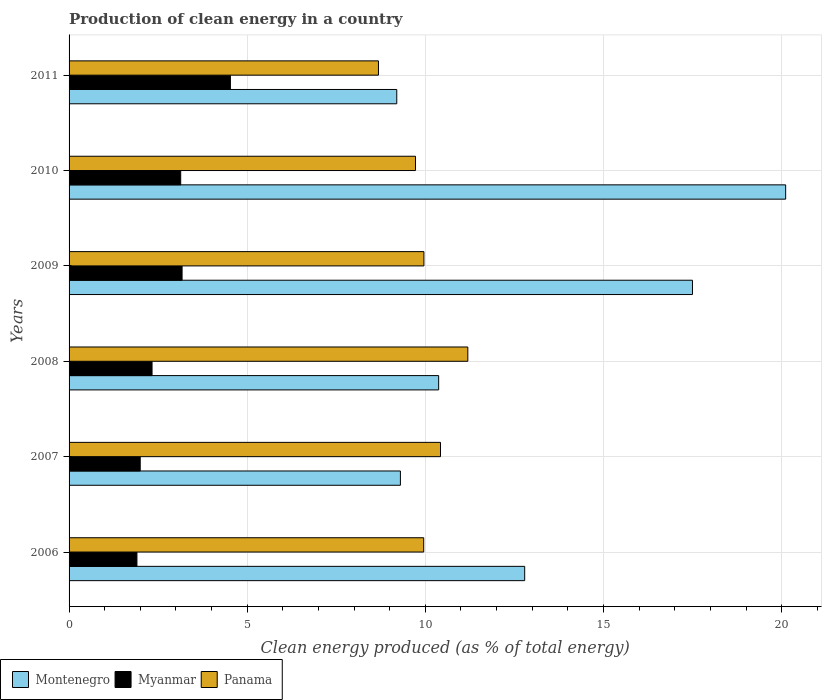How many different coloured bars are there?
Make the answer very short. 3. Are the number of bars per tick equal to the number of legend labels?
Offer a terse response. Yes. How many bars are there on the 2nd tick from the top?
Offer a terse response. 3. What is the label of the 3rd group of bars from the top?
Your answer should be compact. 2009. What is the percentage of clean energy produced in Myanmar in 2011?
Keep it short and to the point. 4.53. Across all years, what is the maximum percentage of clean energy produced in Montenegro?
Give a very brief answer. 20.11. Across all years, what is the minimum percentage of clean energy produced in Myanmar?
Make the answer very short. 1.9. In which year was the percentage of clean energy produced in Myanmar maximum?
Your response must be concise. 2011. What is the total percentage of clean energy produced in Myanmar in the graph?
Ensure brevity in your answer.  17.06. What is the difference between the percentage of clean energy produced in Myanmar in 2007 and that in 2008?
Your answer should be compact. -0.33. What is the difference between the percentage of clean energy produced in Montenegro in 2006 and the percentage of clean energy produced in Myanmar in 2008?
Provide a short and direct response. 10.46. What is the average percentage of clean energy produced in Panama per year?
Your answer should be very brief. 9.99. In the year 2008, what is the difference between the percentage of clean energy produced in Panama and percentage of clean energy produced in Myanmar?
Your response must be concise. 8.86. What is the ratio of the percentage of clean energy produced in Panama in 2006 to that in 2011?
Your response must be concise. 1.15. Is the percentage of clean energy produced in Myanmar in 2006 less than that in 2007?
Keep it short and to the point. Yes. Is the difference between the percentage of clean energy produced in Panama in 2006 and 2011 greater than the difference between the percentage of clean energy produced in Myanmar in 2006 and 2011?
Ensure brevity in your answer.  Yes. What is the difference between the highest and the second highest percentage of clean energy produced in Montenegro?
Give a very brief answer. 2.62. What is the difference between the highest and the lowest percentage of clean energy produced in Panama?
Your answer should be compact. 2.51. Is the sum of the percentage of clean energy produced in Panama in 2006 and 2010 greater than the maximum percentage of clean energy produced in Montenegro across all years?
Your answer should be very brief. No. What does the 1st bar from the top in 2008 represents?
Keep it short and to the point. Panama. What does the 1st bar from the bottom in 2010 represents?
Ensure brevity in your answer.  Montenegro. How many bars are there?
Offer a terse response. 18. How many years are there in the graph?
Offer a very short reply. 6. What is the difference between two consecutive major ticks on the X-axis?
Your answer should be compact. 5. Are the values on the major ticks of X-axis written in scientific E-notation?
Keep it short and to the point. No. Does the graph contain any zero values?
Provide a succinct answer. No. Does the graph contain grids?
Your response must be concise. Yes. How are the legend labels stacked?
Keep it short and to the point. Horizontal. What is the title of the graph?
Offer a terse response. Production of clean energy in a country. Does "Panama" appear as one of the legend labels in the graph?
Ensure brevity in your answer.  Yes. What is the label or title of the X-axis?
Your response must be concise. Clean energy produced (as % of total energy). What is the label or title of the Y-axis?
Ensure brevity in your answer.  Years. What is the Clean energy produced (as % of total energy) in Montenegro in 2006?
Ensure brevity in your answer.  12.79. What is the Clean energy produced (as % of total energy) in Myanmar in 2006?
Make the answer very short. 1.9. What is the Clean energy produced (as % of total energy) of Panama in 2006?
Provide a short and direct response. 9.95. What is the Clean energy produced (as % of total energy) of Montenegro in 2007?
Provide a short and direct response. 9.3. What is the Clean energy produced (as % of total energy) in Myanmar in 2007?
Your response must be concise. 2. What is the Clean energy produced (as % of total energy) in Panama in 2007?
Your answer should be compact. 10.43. What is the Clean energy produced (as % of total energy) in Montenegro in 2008?
Provide a short and direct response. 10.37. What is the Clean energy produced (as % of total energy) in Myanmar in 2008?
Your answer should be compact. 2.33. What is the Clean energy produced (as % of total energy) in Panama in 2008?
Provide a short and direct response. 11.19. What is the Clean energy produced (as % of total energy) in Montenegro in 2009?
Your answer should be very brief. 17.5. What is the Clean energy produced (as % of total energy) of Myanmar in 2009?
Offer a terse response. 3.17. What is the Clean energy produced (as % of total energy) in Panama in 2009?
Give a very brief answer. 9.96. What is the Clean energy produced (as % of total energy) in Montenegro in 2010?
Your answer should be compact. 20.11. What is the Clean energy produced (as % of total energy) of Myanmar in 2010?
Ensure brevity in your answer.  3.13. What is the Clean energy produced (as % of total energy) in Panama in 2010?
Give a very brief answer. 9.72. What is the Clean energy produced (as % of total energy) in Montenegro in 2011?
Your answer should be very brief. 9.2. What is the Clean energy produced (as % of total energy) of Myanmar in 2011?
Your answer should be very brief. 4.53. What is the Clean energy produced (as % of total energy) in Panama in 2011?
Offer a terse response. 8.68. Across all years, what is the maximum Clean energy produced (as % of total energy) in Montenegro?
Provide a succinct answer. 20.11. Across all years, what is the maximum Clean energy produced (as % of total energy) in Myanmar?
Offer a terse response. 4.53. Across all years, what is the maximum Clean energy produced (as % of total energy) of Panama?
Make the answer very short. 11.19. Across all years, what is the minimum Clean energy produced (as % of total energy) of Montenegro?
Your answer should be very brief. 9.2. Across all years, what is the minimum Clean energy produced (as % of total energy) in Myanmar?
Your answer should be very brief. 1.9. Across all years, what is the minimum Clean energy produced (as % of total energy) in Panama?
Make the answer very short. 8.68. What is the total Clean energy produced (as % of total energy) of Montenegro in the graph?
Provide a short and direct response. 79.27. What is the total Clean energy produced (as % of total energy) of Myanmar in the graph?
Make the answer very short. 17.06. What is the total Clean energy produced (as % of total energy) in Panama in the graph?
Give a very brief answer. 59.94. What is the difference between the Clean energy produced (as % of total energy) in Montenegro in 2006 and that in 2007?
Offer a terse response. 3.49. What is the difference between the Clean energy produced (as % of total energy) of Myanmar in 2006 and that in 2007?
Make the answer very short. -0.09. What is the difference between the Clean energy produced (as % of total energy) of Panama in 2006 and that in 2007?
Your answer should be very brief. -0.47. What is the difference between the Clean energy produced (as % of total energy) in Montenegro in 2006 and that in 2008?
Your answer should be very brief. 2.41. What is the difference between the Clean energy produced (as % of total energy) in Myanmar in 2006 and that in 2008?
Give a very brief answer. -0.42. What is the difference between the Clean energy produced (as % of total energy) of Panama in 2006 and that in 2008?
Give a very brief answer. -1.24. What is the difference between the Clean energy produced (as % of total energy) of Montenegro in 2006 and that in 2009?
Offer a terse response. -4.71. What is the difference between the Clean energy produced (as % of total energy) of Myanmar in 2006 and that in 2009?
Make the answer very short. -1.27. What is the difference between the Clean energy produced (as % of total energy) in Panama in 2006 and that in 2009?
Ensure brevity in your answer.  -0.01. What is the difference between the Clean energy produced (as % of total energy) of Montenegro in 2006 and that in 2010?
Make the answer very short. -7.33. What is the difference between the Clean energy produced (as % of total energy) in Myanmar in 2006 and that in 2010?
Provide a succinct answer. -1.23. What is the difference between the Clean energy produced (as % of total energy) of Panama in 2006 and that in 2010?
Your response must be concise. 0.23. What is the difference between the Clean energy produced (as % of total energy) of Montenegro in 2006 and that in 2011?
Make the answer very short. 3.59. What is the difference between the Clean energy produced (as % of total energy) in Myanmar in 2006 and that in 2011?
Your response must be concise. -2.62. What is the difference between the Clean energy produced (as % of total energy) in Panama in 2006 and that in 2011?
Keep it short and to the point. 1.27. What is the difference between the Clean energy produced (as % of total energy) in Montenegro in 2007 and that in 2008?
Provide a succinct answer. -1.07. What is the difference between the Clean energy produced (as % of total energy) of Myanmar in 2007 and that in 2008?
Keep it short and to the point. -0.33. What is the difference between the Clean energy produced (as % of total energy) in Panama in 2007 and that in 2008?
Offer a very short reply. -0.77. What is the difference between the Clean energy produced (as % of total energy) of Montenegro in 2007 and that in 2009?
Offer a very short reply. -8.2. What is the difference between the Clean energy produced (as % of total energy) of Myanmar in 2007 and that in 2009?
Offer a very short reply. -1.18. What is the difference between the Clean energy produced (as % of total energy) of Panama in 2007 and that in 2009?
Make the answer very short. 0.47. What is the difference between the Clean energy produced (as % of total energy) in Montenegro in 2007 and that in 2010?
Ensure brevity in your answer.  -10.81. What is the difference between the Clean energy produced (as % of total energy) in Myanmar in 2007 and that in 2010?
Ensure brevity in your answer.  -1.14. What is the difference between the Clean energy produced (as % of total energy) in Panama in 2007 and that in 2010?
Ensure brevity in your answer.  0.7. What is the difference between the Clean energy produced (as % of total energy) of Montenegro in 2007 and that in 2011?
Provide a short and direct response. 0.1. What is the difference between the Clean energy produced (as % of total energy) in Myanmar in 2007 and that in 2011?
Keep it short and to the point. -2.53. What is the difference between the Clean energy produced (as % of total energy) in Panama in 2007 and that in 2011?
Offer a terse response. 1.74. What is the difference between the Clean energy produced (as % of total energy) of Montenegro in 2008 and that in 2009?
Provide a short and direct response. -7.12. What is the difference between the Clean energy produced (as % of total energy) in Myanmar in 2008 and that in 2009?
Provide a short and direct response. -0.84. What is the difference between the Clean energy produced (as % of total energy) of Panama in 2008 and that in 2009?
Keep it short and to the point. 1.23. What is the difference between the Clean energy produced (as % of total energy) in Montenegro in 2008 and that in 2010?
Provide a short and direct response. -9.74. What is the difference between the Clean energy produced (as % of total energy) of Myanmar in 2008 and that in 2010?
Keep it short and to the point. -0.8. What is the difference between the Clean energy produced (as % of total energy) in Panama in 2008 and that in 2010?
Offer a terse response. 1.47. What is the difference between the Clean energy produced (as % of total energy) of Montenegro in 2008 and that in 2011?
Offer a very short reply. 1.18. What is the difference between the Clean energy produced (as % of total energy) in Myanmar in 2008 and that in 2011?
Keep it short and to the point. -2.2. What is the difference between the Clean energy produced (as % of total energy) of Panama in 2008 and that in 2011?
Your response must be concise. 2.51. What is the difference between the Clean energy produced (as % of total energy) in Montenegro in 2009 and that in 2010?
Ensure brevity in your answer.  -2.62. What is the difference between the Clean energy produced (as % of total energy) in Myanmar in 2009 and that in 2010?
Offer a very short reply. 0.04. What is the difference between the Clean energy produced (as % of total energy) of Panama in 2009 and that in 2010?
Give a very brief answer. 0.24. What is the difference between the Clean energy produced (as % of total energy) in Montenegro in 2009 and that in 2011?
Provide a succinct answer. 8.3. What is the difference between the Clean energy produced (as % of total energy) in Myanmar in 2009 and that in 2011?
Offer a very short reply. -1.36. What is the difference between the Clean energy produced (as % of total energy) in Panama in 2009 and that in 2011?
Make the answer very short. 1.28. What is the difference between the Clean energy produced (as % of total energy) in Montenegro in 2010 and that in 2011?
Give a very brief answer. 10.92. What is the difference between the Clean energy produced (as % of total energy) of Myanmar in 2010 and that in 2011?
Your answer should be compact. -1.4. What is the difference between the Clean energy produced (as % of total energy) in Panama in 2010 and that in 2011?
Provide a short and direct response. 1.04. What is the difference between the Clean energy produced (as % of total energy) in Montenegro in 2006 and the Clean energy produced (as % of total energy) in Myanmar in 2007?
Provide a short and direct response. 10.79. What is the difference between the Clean energy produced (as % of total energy) in Montenegro in 2006 and the Clean energy produced (as % of total energy) in Panama in 2007?
Keep it short and to the point. 2.36. What is the difference between the Clean energy produced (as % of total energy) of Myanmar in 2006 and the Clean energy produced (as % of total energy) of Panama in 2007?
Your response must be concise. -8.52. What is the difference between the Clean energy produced (as % of total energy) of Montenegro in 2006 and the Clean energy produced (as % of total energy) of Myanmar in 2008?
Make the answer very short. 10.46. What is the difference between the Clean energy produced (as % of total energy) of Montenegro in 2006 and the Clean energy produced (as % of total energy) of Panama in 2008?
Give a very brief answer. 1.6. What is the difference between the Clean energy produced (as % of total energy) of Myanmar in 2006 and the Clean energy produced (as % of total energy) of Panama in 2008?
Provide a succinct answer. -9.29. What is the difference between the Clean energy produced (as % of total energy) in Montenegro in 2006 and the Clean energy produced (as % of total energy) in Myanmar in 2009?
Make the answer very short. 9.62. What is the difference between the Clean energy produced (as % of total energy) of Montenegro in 2006 and the Clean energy produced (as % of total energy) of Panama in 2009?
Your answer should be compact. 2.83. What is the difference between the Clean energy produced (as % of total energy) in Myanmar in 2006 and the Clean energy produced (as % of total energy) in Panama in 2009?
Provide a short and direct response. -8.05. What is the difference between the Clean energy produced (as % of total energy) of Montenegro in 2006 and the Clean energy produced (as % of total energy) of Myanmar in 2010?
Ensure brevity in your answer.  9.65. What is the difference between the Clean energy produced (as % of total energy) in Montenegro in 2006 and the Clean energy produced (as % of total energy) in Panama in 2010?
Offer a terse response. 3.06. What is the difference between the Clean energy produced (as % of total energy) of Myanmar in 2006 and the Clean energy produced (as % of total energy) of Panama in 2010?
Your answer should be very brief. -7.82. What is the difference between the Clean energy produced (as % of total energy) of Montenegro in 2006 and the Clean energy produced (as % of total energy) of Myanmar in 2011?
Offer a very short reply. 8.26. What is the difference between the Clean energy produced (as % of total energy) of Montenegro in 2006 and the Clean energy produced (as % of total energy) of Panama in 2011?
Offer a very short reply. 4.1. What is the difference between the Clean energy produced (as % of total energy) of Myanmar in 2006 and the Clean energy produced (as % of total energy) of Panama in 2011?
Provide a short and direct response. -6.78. What is the difference between the Clean energy produced (as % of total energy) of Montenegro in 2007 and the Clean energy produced (as % of total energy) of Myanmar in 2008?
Offer a very short reply. 6.97. What is the difference between the Clean energy produced (as % of total energy) of Montenegro in 2007 and the Clean energy produced (as % of total energy) of Panama in 2008?
Your response must be concise. -1.89. What is the difference between the Clean energy produced (as % of total energy) of Myanmar in 2007 and the Clean energy produced (as % of total energy) of Panama in 2008?
Give a very brief answer. -9.2. What is the difference between the Clean energy produced (as % of total energy) of Montenegro in 2007 and the Clean energy produced (as % of total energy) of Myanmar in 2009?
Your response must be concise. 6.13. What is the difference between the Clean energy produced (as % of total energy) in Montenegro in 2007 and the Clean energy produced (as % of total energy) in Panama in 2009?
Your answer should be compact. -0.66. What is the difference between the Clean energy produced (as % of total energy) of Myanmar in 2007 and the Clean energy produced (as % of total energy) of Panama in 2009?
Ensure brevity in your answer.  -7.96. What is the difference between the Clean energy produced (as % of total energy) of Montenegro in 2007 and the Clean energy produced (as % of total energy) of Myanmar in 2010?
Ensure brevity in your answer.  6.17. What is the difference between the Clean energy produced (as % of total energy) in Montenegro in 2007 and the Clean energy produced (as % of total energy) in Panama in 2010?
Make the answer very short. -0.42. What is the difference between the Clean energy produced (as % of total energy) of Myanmar in 2007 and the Clean energy produced (as % of total energy) of Panama in 2010?
Give a very brief answer. -7.73. What is the difference between the Clean energy produced (as % of total energy) in Montenegro in 2007 and the Clean energy produced (as % of total energy) in Myanmar in 2011?
Give a very brief answer. 4.77. What is the difference between the Clean energy produced (as % of total energy) in Montenegro in 2007 and the Clean energy produced (as % of total energy) in Panama in 2011?
Give a very brief answer. 0.62. What is the difference between the Clean energy produced (as % of total energy) of Myanmar in 2007 and the Clean energy produced (as % of total energy) of Panama in 2011?
Make the answer very short. -6.69. What is the difference between the Clean energy produced (as % of total energy) of Montenegro in 2008 and the Clean energy produced (as % of total energy) of Myanmar in 2009?
Give a very brief answer. 7.2. What is the difference between the Clean energy produced (as % of total energy) in Montenegro in 2008 and the Clean energy produced (as % of total energy) in Panama in 2009?
Offer a very short reply. 0.41. What is the difference between the Clean energy produced (as % of total energy) in Myanmar in 2008 and the Clean energy produced (as % of total energy) in Panama in 2009?
Ensure brevity in your answer.  -7.63. What is the difference between the Clean energy produced (as % of total energy) of Montenegro in 2008 and the Clean energy produced (as % of total energy) of Myanmar in 2010?
Provide a succinct answer. 7.24. What is the difference between the Clean energy produced (as % of total energy) in Montenegro in 2008 and the Clean energy produced (as % of total energy) in Panama in 2010?
Your answer should be compact. 0.65. What is the difference between the Clean energy produced (as % of total energy) in Myanmar in 2008 and the Clean energy produced (as % of total energy) in Panama in 2010?
Give a very brief answer. -7.39. What is the difference between the Clean energy produced (as % of total energy) in Montenegro in 2008 and the Clean energy produced (as % of total energy) in Myanmar in 2011?
Keep it short and to the point. 5.85. What is the difference between the Clean energy produced (as % of total energy) in Montenegro in 2008 and the Clean energy produced (as % of total energy) in Panama in 2011?
Offer a very short reply. 1.69. What is the difference between the Clean energy produced (as % of total energy) of Myanmar in 2008 and the Clean energy produced (as % of total energy) of Panama in 2011?
Make the answer very short. -6.36. What is the difference between the Clean energy produced (as % of total energy) in Montenegro in 2009 and the Clean energy produced (as % of total energy) in Myanmar in 2010?
Ensure brevity in your answer.  14.36. What is the difference between the Clean energy produced (as % of total energy) in Montenegro in 2009 and the Clean energy produced (as % of total energy) in Panama in 2010?
Offer a very short reply. 7.77. What is the difference between the Clean energy produced (as % of total energy) of Myanmar in 2009 and the Clean energy produced (as % of total energy) of Panama in 2010?
Offer a very short reply. -6.55. What is the difference between the Clean energy produced (as % of total energy) of Montenegro in 2009 and the Clean energy produced (as % of total energy) of Myanmar in 2011?
Keep it short and to the point. 12.97. What is the difference between the Clean energy produced (as % of total energy) of Montenegro in 2009 and the Clean energy produced (as % of total energy) of Panama in 2011?
Your response must be concise. 8.81. What is the difference between the Clean energy produced (as % of total energy) in Myanmar in 2009 and the Clean energy produced (as % of total energy) in Panama in 2011?
Your response must be concise. -5.51. What is the difference between the Clean energy produced (as % of total energy) of Montenegro in 2010 and the Clean energy produced (as % of total energy) of Myanmar in 2011?
Your answer should be compact. 15.58. What is the difference between the Clean energy produced (as % of total energy) in Montenegro in 2010 and the Clean energy produced (as % of total energy) in Panama in 2011?
Keep it short and to the point. 11.43. What is the difference between the Clean energy produced (as % of total energy) of Myanmar in 2010 and the Clean energy produced (as % of total energy) of Panama in 2011?
Offer a very short reply. -5.55. What is the average Clean energy produced (as % of total energy) in Montenegro per year?
Offer a very short reply. 13.21. What is the average Clean energy produced (as % of total energy) in Myanmar per year?
Your answer should be compact. 2.84. What is the average Clean energy produced (as % of total energy) of Panama per year?
Your answer should be compact. 9.99. In the year 2006, what is the difference between the Clean energy produced (as % of total energy) of Montenegro and Clean energy produced (as % of total energy) of Myanmar?
Offer a terse response. 10.88. In the year 2006, what is the difference between the Clean energy produced (as % of total energy) in Montenegro and Clean energy produced (as % of total energy) in Panama?
Keep it short and to the point. 2.83. In the year 2006, what is the difference between the Clean energy produced (as % of total energy) in Myanmar and Clean energy produced (as % of total energy) in Panama?
Your answer should be compact. -8.05. In the year 2007, what is the difference between the Clean energy produced (as % of total energy) of Montenegro and Clean energy produced (as % of total energy) of Myanmar?
Keep it short and to the point. 7.3. In the year 2007, what is the difference between the Clean energy produced (as % of total energy) of Montenegro and Clean energy produced (as % of total energy) of Panama?
Your response must be concise. -1.13. In the year 2007, what is the difference between the Clean energy produced (as % of total energy) in Myanmar and Clean energy produced (as % of total energy) in Panama?
Provide a short and direct response. -8.43. In the year 2008, what is the difference between the Clean energy produced (as % of total energy) of Montenegro and Clean energy produced (as % of total energy) of Myanmar?
Provide a short and direct response. 8.04. In the year 2008, what is the difference between the Clean energy produced (as % of total energy) of Montenegro and Clean energy produced (as % of total energy) of Panama?
Your response must be concise. -0.82. In the year 2008, what is the difference between the Clean energy produced (as % of total energy) in Myanmar and Clean energy produced (as % of total energy) in Panama?
Provide a succinct answer. -8.86. In the year 2009, what is the difference between the Clean energy produced (as % of total energy) of Montenegro and Clean energy produced (as % of total energy) of Myanmar?
Keep it short and to the point. 14.33. In the year 2009, what is the difference between the Clean energy produced (as % of total energy) in Montenegro and Clean energy produced (as % of total energy) in Panama?
Offer a very short reply. 7.54. In the year 2009, what is the difference between the Clean energy produced (as % of total energy) in Myanmar and Clean energy produced (as % of total energy) in Panama?
Give a very brief answer. -6.79. In the year 2010, what is the difference between the Clean energy produced (as % of total energy) of Montenegro and Clean energy produced (as % of total energy) of Myanmar?
Provide a short and direct response. 16.98. In the year 2010, what is the difference between the Clean energy produced (as % of total energy) of Montenegro and Clean energy produced (as % of total energy) of Panama?
Your answer should be very brief. 10.39. In the year 2010, what is the difference between the Clean energy produced (as % of total energy) in Myanmar and Clean energy produced (as % of total energy) in Panama?
Offer a very short reply. -6.59. In the year 2011, what is the difference between the Clean energy produced (as % of total energy) of Montenegro and Clean energy produced (as % of total energy) of Myanmar?
Keep it short and to the point. 4.67. In the year 2011, what is the difference between the Clean energy produced (as % of total energy) in Montenegro and Clean energy produced (as % of total energy) in Panama?
Ensure brevity in your answer.  0.51. In the year 2011, what is the difference between the Clean energy produced (as % of total energy) of Myanmar and Clean energy produced (as % of total energy) of Panama?
Provide a short and direct response. -4.16. What is the ratio of the Clean energy produced (as % of total energy) in Montenegro in 2006 to that in 2007?
Provide a short and direct response. 1.38. What is the ratio of the Clean energy produced (as % of total energy) in Myanmar in 2006 to that in 2007?
Make the answer very short. 0.95. What is the ratio of the Clean energy produced (as % of total energy) in Panama in 2006 to that in 2007?
Provide a short and direct response. 0.95. What is the ratio of the Clean energy produced (as % of total energy) in Montenegro in 2006 to that in 2008?
Give a very brief answer. 1.23. What is the ratio of the Clean energy produced (as % of total energy) of Myanmar in 2006 to that in 2008?
Make the answer very short. 0.82. What is the ratio of the Clean energy produced (as % of total energy) of Panama in 2006 to that in 2008?
Your answer should be compact. 0.89. What is the ratio of the Clean energy produced (as % of total energy) of Montenegro in 2006 to that in 2009?
Keep it short and to the point. 0.73. What is the ratio of the Clean energy produced (as % of total energy) in Myanmar in 2006 to that in 2009?
Keep it short and to the point. 0.6. What is the ratio of the Clean energy produced (as % of total energy) in Montenegro in 2006 to that in 2010?
Keep it short and to the point. 0.64. What is the ratio of the Clean energy produced (as % of total energy) of Myanmar in 2006 to that in 2010?
Your response must be concise. 0.61. What is the ratio of the Clean energy produced (as % of total energy) of Panama in 2006 to that in 2010?
Give a very brief answer. 1.02. What is the ratio of the Clean energy produced (as % of total energy) in Montenegro in 2006 to that in 2011?
Provide a short and direct response. 1.39. What is the ratio of the Clean energy produced (as % of total energy) of Myanmar in 2006 to that in 2011?
Give a very brief answer. 0.42. What is the ratio of the Clean energy produced (as % of total energy) of Panama in 2006 to that in 2011?
Your answer should be compact. 1.15. What is the ratio of the Clean energy produced (as % of total energy) in Montenegro in 2007 to that in 2008?
Ensure brevity in your answer.  0.9. What is the ratio of the Clean energy produced (as % of total energy) in Myanmar in 2007 to that in 2008?
Ensure brevity in your answer.  0.86. What is the ratio of the Clean energy produced (as % of total energy) in Panama in 2007 to that in 2008?
Keep it short and to the point. 0.93. What is the ratio of the Clean energy produced (as % of total energy) of Montenegro in 2007 to that in 2009?
Give a very brief answer. 0.53. What is the ratio of the Clean energy produced (as % of total energy) in Myanmar in 2007 to that in 2009?
Your answer should be compact. 0.63. What is the ratio of the Clean energy produced (as % of total energy) of Panama in 2007 to that in 2009?
Make the answer very short. 1.05. What is the ratio of the Clean energy produced (as % of total energy) in Montenegro in 2007 to that in 2010?
Your answer should be compact. 0.46. What is the ratio of the Clean energy produced (as % of total energy) in Myanmar in 2007 to that in 2010?
Your answer should be very brief. 0.64. What is the ratio of the Clean energy produced (as % of total energy) of Panama in 2007 to that in 2010?
Provide a short and direct response. 1.07. What is the ratio of the Clean energy produced (as % of total energy) in Montenegro in 2007 to that in 2011?
Your answer should be very brief. 1.01. What is the ratio of the Clean energy produced (as % of total energy) of Myanmar in 2007 to that in 2011?
Ensure brevity in your answer.  0.44. What is the ratio of the Clean energy produced (as % of total energy) of Panama in 2007 to that in 2011?
Your answer should be very brief. 1.2. What is the ratio of the Clean energy produced (as % of total energy) of Montenegro in 2008 to that in 2009?
Your answer should be very brief. 0.59. What is the ratio of the Clean energy produced (as % of total energy) in Myanmar in 2008 to that in 2009?
Your response must be concise. 0.73. What is the ratio of the Clean energy produced (as % of total energy) of Panama in 2008 to that in 2009?
Provide a short and direct response. 1.12. What is the ratio of the Clean energy produced (as % of total energy) of Montenegro in 2008 to that in 2010?
Give a very brief answer. 0.52. What is the ratio of the Clean energy produced (as % of total energy) of Myanmar in 2008 to that in 2010?
Ensure brevity in your answer.  0.74. What is the ratio of the Clean energy produced (as % of total energy) of Panama in 2008 to that in 2010?
Your answer should be compact. 1.15. What is the ratio of the Clean energy produced (as % of total energy) of Montenegro in 2008 to that in 2011?
Your answer should be compact. 1.13. What is the ratio of the Clean energy produced (as % of total energy) of Myanmar in 2008 to that in 2011?
Make the answer very short. 0.51. What is the ratio of the Clean energy produced (as % of total energy) of Panama in 2008 to that in 2011?
Your answer should be compact. 1.29. What is the ratio of the Clean energy produced (as % of total energy) of Montenegro in 2009 to that in 2010?
Your answer should be compact. 0.87. What is the ratio of the Clean energy produced (as % of total energy) of Myanmar in 2009 to that in 2010?
Provide a short and direct response. 1.01. What is the ratio of the Clean energy produced (as % of total energy) in Panama in 2009 to that in 2010?
Ensure brevity in your answer.  1.02. What is the ratio of the Clean energy produced (as % of total energy) in Montenegro in 2009 to that in 2011?
Offer a very short reply. 1.9. What is the ratio of the Clean energy produced (as % of total energy) of Myanmar in 2009 to that in 2011?
Make the answer very short. 0.7. What is the ratio of the Clean energy produced (as % of total energy) of Panama in 2009 to that in 2011?
Your response must be concise. 1.15. What is the ratio of the Clean energy produced (as % of total energy) in Montenegro in 2010 to that in 2011?
Offer a terse response. 2.19. What is the ratio of the Clean energy produced (as % of total energy) of Myanmar in 2010 to that in 2011?
Offer a terse response. 0.69. What is the ratio of the Clean energy produced (as % of total energy) in Panama in 2010 to that in 2011?
Offer a very short reply. 1.12. What is the difference between the highest and the second highest Clean energy produced (as % of total energy) of Montenegro?
Offer a very short reply. 2.62. What is the difference between the highest and the second highest Clean energy produced (as % of total energy) of Myanmar?
Your answer should be compact. 1.36. What is the difference between the highest and the second highest Clean energy produced (as % of total energy) of Panama?
Your response must be concise. 0.77. What is the difference between the highest and the lowest Clean energy produced (as % of total energy) in Montenegro?
Your response must be concise. 10.92. What is the difference between the highest and the lowest Clean energy produced (as % of total energy) of Myanmar?
Your response must be concise. 2.62. What is the difference between the highest and the lowest Clean energy produced (as % of total energy) in Panama?
Your answer should be very brief. 2.51. 